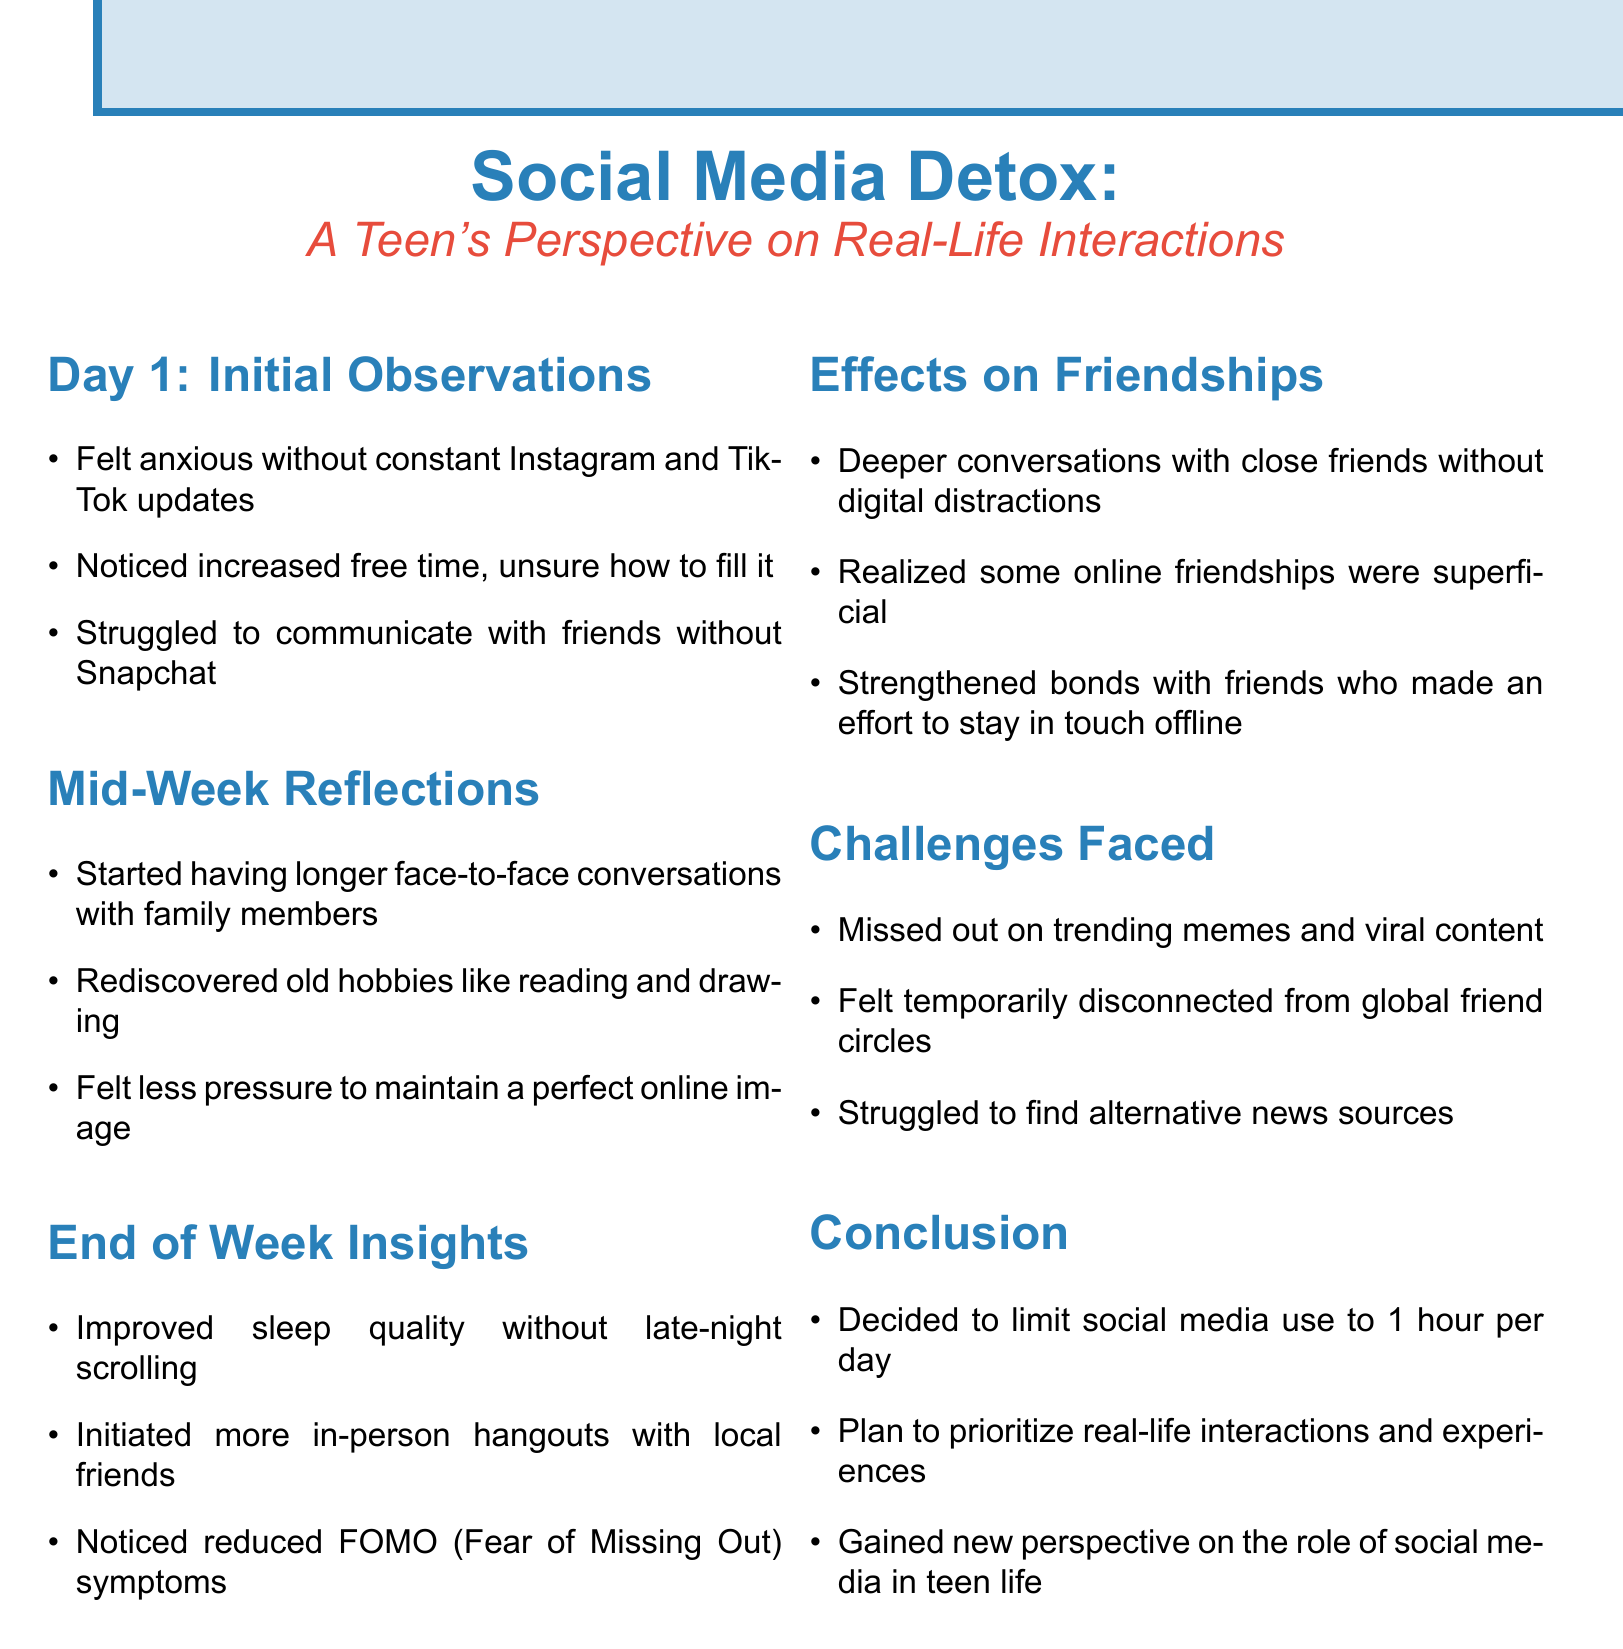What did the teenager feel on Day 1 without social media? The document states that the teenager felt anxious without constant Instagram and TikTok updates.
Answer: anxious What hobby did the teenager rediscover mid-week? According to the document, the teenager rediscovered old hobbies like reading and drawing.
Answer: reading and drawing How did the teenager's sleep quality change by the end of the week? The document mentions improved sleep quality without late-night scrolling.
Answer: improved What realization did the teenager have about online friendships? The teenager realized that some online friendships were superficial.
Answer: superficial What is the teenager's new social media usage plan? The teenager decided to limit social media use to 1 hour per day.
Answer: 1 hour per day What emotion was reduced by the end of the week? The document indicates that the teenager noticed reduced FOMO (Fear of Missing Out) symptoms.
Answer: FOMO Which family members did the teenager have longer conversations with? The teenager started having longer face-to-face conversations with family members.
Answer: family members What was one of the challenges faced during the detox? The document lists missing out on trending memes and viral content as a challenge faced.
Answer: trending memes How did the detox affect in-person hangouts? The teenager initiated more in-person hangouts with local friends during the detox.
Answer: more in-person hangouts 